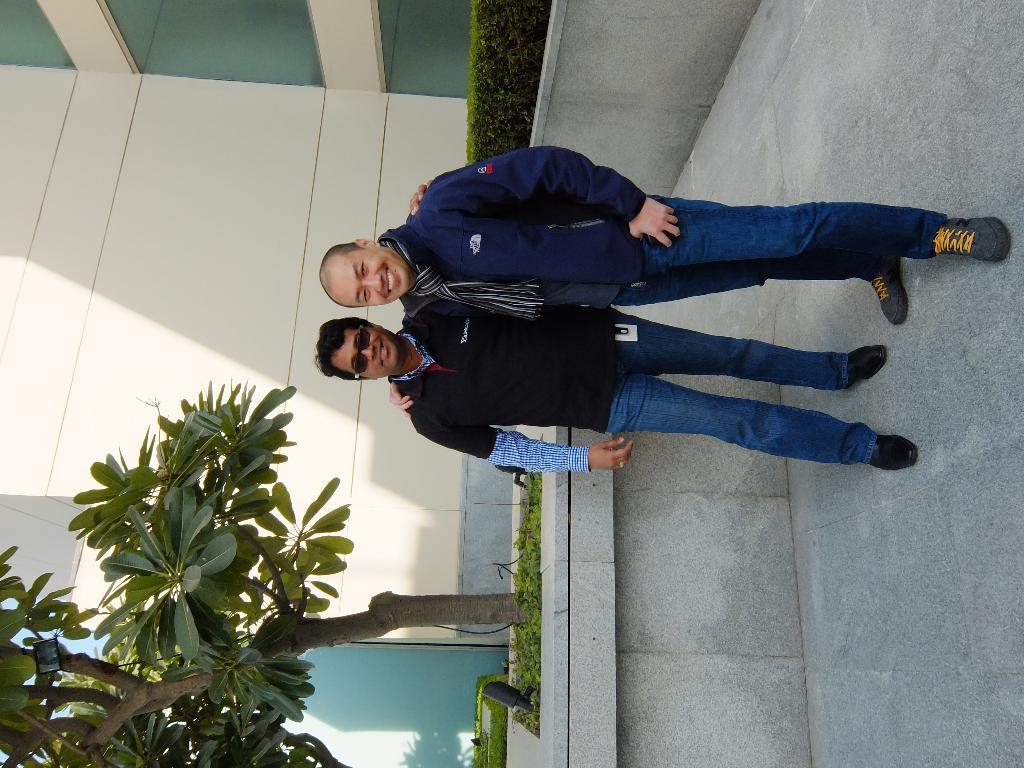How would you summarize this image in a sentence or two? In this image in the center there are two people standing and they are smiling, and in the background there is a tree, plants, wall, building. And on the right side of the image there is walkway. 